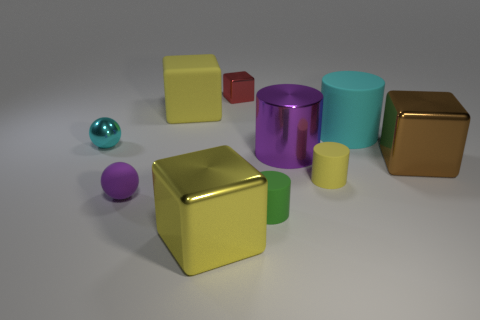How many things are tiny purple objects or small cubes?
Your answer should be very brief. 2. Are there any tiny green objects?
Your answer should be very brief. Yes. What is the material of the cyan object on the left side of the yellow rubber object that is in front of the cyan object on the left side of the cyan matte thing?
Keep it short and to the point. Metal. Is the number of tiny green things on the right side of the brown object less than the number of big rubber cylinders?
Make the answer very short. Yes. There is a purple cylinder that is the same size as the brown block; what is its material?
Offer a terse response. Metal. There is a matte thing that is behind the metallic cylinder and in front of the matte block; what size is it?
Give a very brief answer. Large. What is the size of the brown object that is the same shape as the small red object?
Ensure brevity in your answer.  Large. What number of objects are cyan rubber cylinders or rubber cylinders behind the brown metal thing?
Make the answer very short. 1. What is the shape of the cyan metal thing?
Provide a succinct answer. Sphere. What shape is the small shiny object that is right of the big cube that is behind the large metal cylinder?
Provide a succinct answer. Cube. 